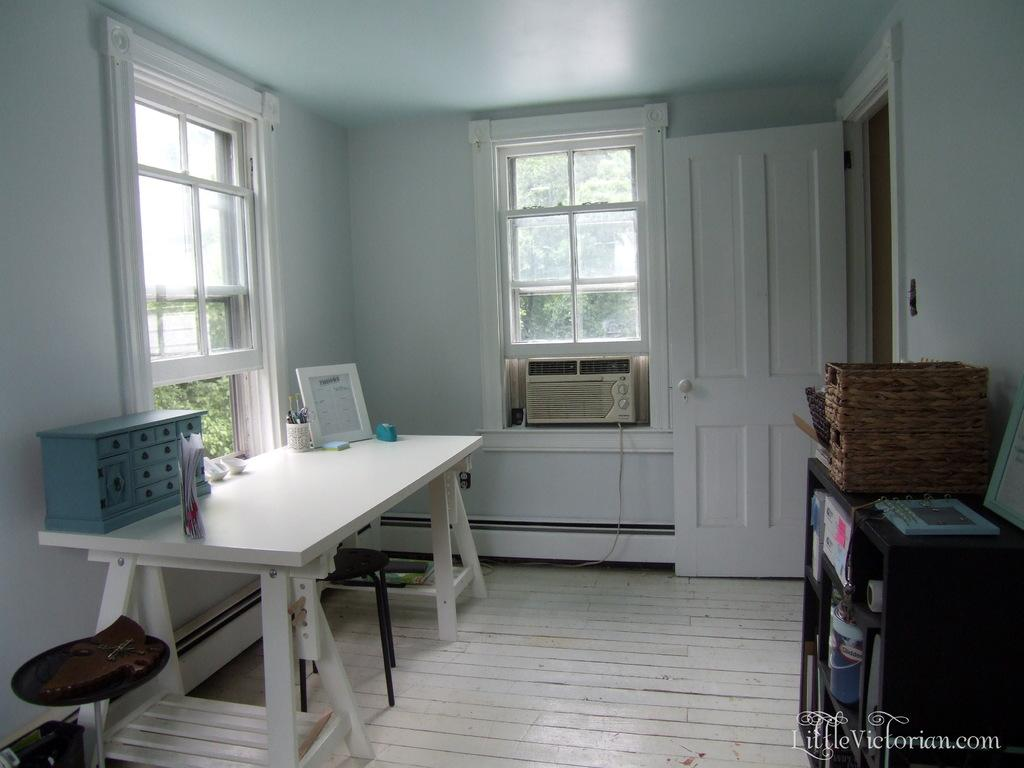What is located on the left side of the image? There is a white color table on the left side of the image. What architectural features can be seen on the left side of the image? There are two windows on the left side of the image. What is located on the right side of the image? There is a door on the right side of the image. Can you see the owner holding a rifle in the image? There is no person or rifle present in the image. What type of lipstick is the person wearing in the image? There is no person or lipstick present in the image. 